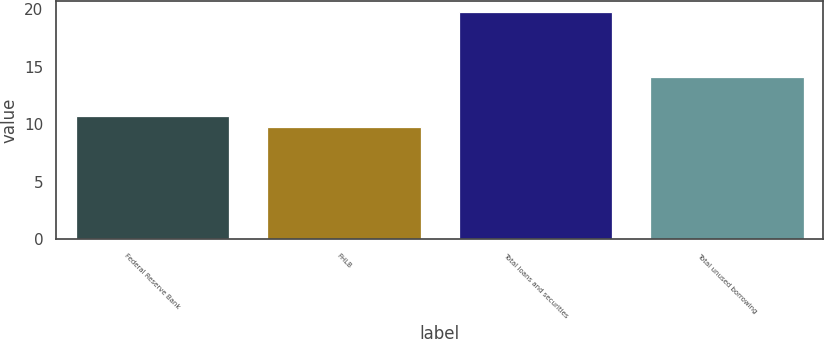Convert chart to OTSL. <chart><loc_0><loc_0><loc_500><loc_500><bar_chart><fcel>Federal Reserve Bank<fcel>FHLB<fcel>Total loans and securities<fcel>Total unused borrowing<nl><fcel>10.7<fcel>9.7<fcel>19.7<fcel>14.1<nl></chart> 